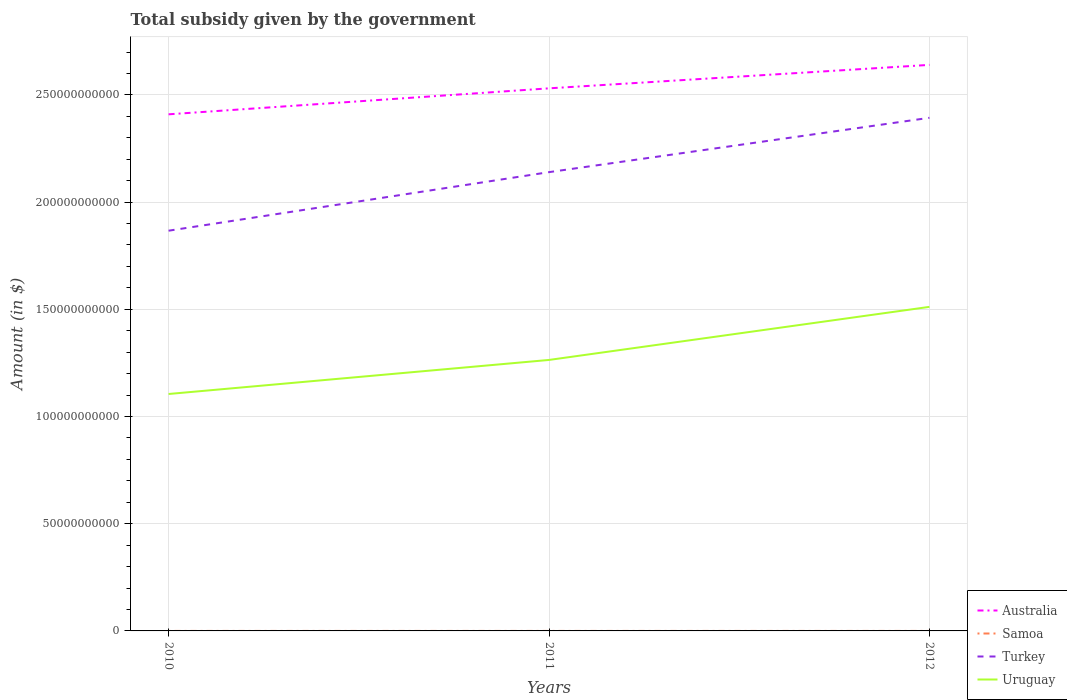Is the number of lines equal to the number of legend labels?
Give a very brief answer. Yes. Across all years, what is the maximum total revenue collected by the government in Uruguay?
Offer a very short reply. 1.11e+11. In which year was the total revenue collected by the government in Samoa maximum?
Your response must be concise. 2012. What is the total total revenue collected by the government in Turkey in the graph?
Make the answer very short. -2.53e+1. What is the difference between the highest and the second highest total revenue collected by the government in Australia?
Make the answer very short. 2.31e+1. What is the difference between two consecutive major ticks on the Y-axis?
Provide a succinct answer. 5.00e+1. Does the graph contain grids?
Ensure brevity in your answer.  Yes. Where does the legend appear in the graph?
Provide a succinct answer. Bottom right. How many legend labels are there?
Offer a very short reply. 4. How are the legend labels stacked?
Provide a short and direct response. Vertical. What is the title of the graph?
Offer a terse response. Total subsidy given by the government. Does "Guatemala" appear as one of the legend labels in the graph?
Your response must be concise. No. What is the label or title of the Y-axis?
Your answer should be very brief. Amount (in $). What is the Amount (in $) in Australia in 2010?
Offer a terse response. 2.41e+11. What is the Amount (in $) in Samoa in 2010?
Your answer should be compact. 1.88e+05. What is the Amount (in $) of Turkey in 2010?
Your response must be concise. 1.87e+11. What is the Amount (in $) of Uruguay in 2010?
Provide a short and direct response. 1.11e+11. What is the Amount (in $) in Australia in 2011?
Provide a short and direct response. 2.53e+11. What is the Amount (in $) in Samoa in 2011?
Your answer should be very brief. 1.84e+05. What is the Amount (in $) of Turkey in 2011?
Offer a very short reply. 2.14e+11. What is the Amount (in $) in Uruguay in 2011?
Provide a succinct answer. 1.26e+11. What is the Amount (in $) in Australia in 2012?
Provide a succinct answer. 2.64e+11. What is the Amount (in $) in Samoa in 2012?
Ensure brevity in your answer.  1.76e+05. What is the Amount (in $) of Turkey in 2012?
Provide a succinct answer. 2.39e+11. What is the Amount (in $) in Uruguay in 2012?
Provide a short and direct response. 1.51e+11. Across all years, what is the maximum Amount (in $) of Australia?
Offer a terse response. 2.64e+11. Across all years, what is the maximum Amount (in $) of Samoa?
Provide a short and direct response. 1.88e+05. Across all years, what is the maximum Amount (in $) in Turkey?
Provide a succinct answer. 2.39e+11. Across all years, what is the maximum Amount (in $) in Uruguay?
Keep it short and to the point. 1.51e+11. Across all years, what is the minimum Amount (in $) of Australia?
Provide a short and direct response. 2.41e+11. Across all years, what is the minimum Amount (in $) in Samoa?
Offer a very short reply. 1.76e+05. Across all years, what is the minimum Amount (in $) in Turkey?
Your answer should be very brief. 1.87e+11. Across all years, what is the minimum Amount (in $) of Uruguay?
Keep it short and to the point. 1.11e+11. What is the total Amount (in $) of Australia in the graph?
Keep it short and to the point. 7.58e+11. What is the total Amount (in $) of Samoa in the graph?
Provide a succinct answer. 5.48e+05. What is the total Amount (in $) of Turkey in the graph?
Offer a very short reply. 6.40e+11. What is the total Amount (in $) of Uruguay in the graph?
Provide a short and direct response. 3.88e+11. What is the difference between the Amount (in $) in Australia in 2010 and that in 2011?
Your response must be concise. -1.21e+1. What is the difference between the Amount (in $) of Samoa in 2010 and that in 2011?
Ensure brevity in your answer.  4748.99. What is the difference between the Amount (in $) in Turkey in 2010 and that in 2011?
Offer a very short reply. -2.73e+1. What is the difference between the Amount (in $) of Uruguay in 2010 and that in 2011?
Keep it short and to the point. -1.59e+1. What is the difference between the Amount (in $) in Australia in 2010 and that in 2012?
Your answer should be compact. -2.31e+1. What is the difference between the Amount (in $) in Samoa in 2010 and that in 2012?
Your answer should be compact. 1.25e+04. What is the difference between the Amount (in $) of Turkey in 2010 and that in 2012?
Ensure brevity in your answer.  -5.27e+1. What is the difference between the Amount (in $) in Uruguay in 2010 and that in 2012?
Give a very brief answer. -4.06e+1. What is the difference between the Amount (in $) of Australia in 2011 and that in 2012?
Your answer should be very brief. -1.09e+1. What is the difference between the Amount (in $) in Samoa in 2011 and that in 2012?
Keep it short and to the point. 7706.28. What is the difference between the Amount (in $) of Turkey in 2011 and that in 2012?
Provide a succinct answer. -2.53e+1. What is the difference between the Amount (in $) of Uruguay in 2011 and that in 2012?
Provide a short and direct response. -2.48e+1. What is the difference between the Amount (in $) in Australia in 2010 and the Amount (in $) in Samoa in 2011?
Offer a very short reply. 2.41e+11. What is the difference between the Amount (in $) of Australia in 2010 and the Amount (in $) of Turkey in 2011?
Ensure brevity in your answer.  2.70e+1. What is the difference between the Amount (in $) of Australia in 2010 and the Amount (in $) of Uruguay in 2011?
Keep it short and to the point. 1.15e+11. What is the difference between the Amount (in $) in Samoa in 2010 and the Amount (in $) in Turkey in 2011?
Give a very brief answer. -2.14e+11. What is the difference between the Amount (in $) in Samoa in 2010 and the Amount (in $) in Uruguay in 2011?
Provide a succinct answer. -1.26e+11. What is the difference between the Amount (in $) in Turkey in 2010 and the Amount (in $) in Uruguay in 2011?
Your answer should be very brief. 6.03e+1. What is the difference between the Amount (in $) of Australia in 2010 and the Amount (in $) of Samoa in 2012?
Ensure brevity in your answer.  2.41e+11. What is the difference between the Amount (in $) of Australia in 2010 and the Amount (in $) of Turkey in 2012?
Provide a short and direct response. 1.63e+09. What is the difference between the Amount (in $) of Australia in 2010 and the Amount (in $) of Uruguay in 2012?
Offer a very short reply. 8.98e+1. What is the difference between the Amount (in $) of Samoa in 2010 and the Amount (in $) of Turkey in 2012?
Keep it short and to the point. -2.39e+11. What is the difference between the Amount (in $) of Samoa in 2010 and the Amount (in $) of Uruguay in 2012?
Offer a terse response. -1.51e+11. What is the difference between the Amount (in $) in Turkey in 2010 and the Amount (in $) in Uruguay in 2012?
Ensure brevity in your answer.  3.55e+1. What is the difference between the Amount (in $) in Australia in 2011 and the Amount (in $) in Samoa in 2012?
Provide a succinct answer. 2.53e+11. What is the difference between the Amount (in $) of Australia in 2011 and the Amount (in $) of Turkey in 2012?
Offer a very short reply. 1.37e+1. What is the difference between the Amount (in $) in Australia in 2011 and the Amount (in $) in Uruguay in 2012?
Offer a terse response. 1.02e+11. What is the difference between the Amount (in $) in Samoa in 2011 and the Amount (in $) in Turkey in 2012?
Provide a succinct answer. -2.39e+11. What is the difference between the Amount (in $) in Samoa in 2011 and the Amount (in $) in Uruguay in 2012?
Your answer should be very brief. -1.51e+11. What is the difference between the Amount (in $) of Turkey in 2011 and the Amount (in $) of Uruguay in 2012?
Ensure brevity in your answer.  6.28e+1. What is the average Amount (in $) of Australia per year?
Offer a terse response. 2.53e+11. What is the average Amount (in $) in Samoa per year?
Your response must be concise. 1.83e+05. What is the average Amount (in $) of Turkey per year?
Offer a terse response. 2.13e+11. What is the average Amount (in $) in Uruguay per year?
Ensure brevity in your answer.  1.29e+11. In the year 2010, what is the difference between the Amount (in $) in Australia and Amount (in $) in Samoa?
Give a very brief answer. 2.41e+11. In the year 2010, what is the difference between the Amount (in $) of Australia and Amount (in $) of Turkey?
Provide a short and direct response. 5.43e+1. In the year 2010, what is the difference between the Amount (in $) in Australia and Amount (in $) in Uruguay?
Keep it short and to the point. 1.30e+11. In the year 2010, what is the difference between the Amount (in $) of Samoa and Amount (in $) of Turkey?
Keep it short and to the point. -1.87e+11. In the year 2010, what is the difference between the Amount (in $) in Samoa and Amount (in $) in Uruguay?
Offer a terse response. -1.11e+11. In the year 2010, what is the difference between the Amount (in $) of Turkey and Amount (in $) of Uruguay?
Make the answer very short. 7.62e+1. In the year 2011, what is the difference between the Amount (in $) in Australia and Amount (in $) in Samoa?
Your response must be concise. 2.53e+11. In the year 2011, what is the difference between the Amount (in $) of Australia and Amount (in $) of Turkey?
Ensure brevity in your answer.  3.91e+1. In the year 2011, what is the difference between the Amount (in $) in Australia and Amount (in $) in Uruguay?
Offer a very short reply. 1.27e+11. In the year 2011, what is the difference between the Amount (in $) in Samoa and Amount (in $) in Turkey?
Your answer should be compact. -2.14e+11. In the year 2011, what is the difference between the Amount (in $) of Samoa and Amount (in $) of Uruguay?
Offer a very short reply. -1.26e+11. In the year 2011, what is the difference between the Amount (in $) in Turkey and Amount (in $) in Uruguay?
Make the answer very short. 8.76e+1. In the year 2012, what is the difference between the Amount (in $) of Australia and Amount (in $) of Samoa?
Your answer should be very brief. 2.64e+11. In the year 2012, what is the difference between the Amount (in $) in Australia and Amount (in $) in Turkey?
Make the answer very short. 2.47e+1. In the year 2012, what is the difference between the Amount (in $) in Australia and Amount (in $) in Uruguay?
Give a very brief answer. 1.13e+11. In the year 2012, what is the difference between the Amount (in $) in Samoa and Amount (in $) in Turkey?
Keep it short and to the point. -2.39e+11. In the year 2012, what is the difference between the Amount (in $) in Samoa and Amount (in $) in Uruguay?
Make the answer very short. -1.51e+11. In the year 2012, what is the difference between the Amount (in $) of Turkey and Amount (in $) of Uruguay?
Ensure brevity in your answer.  8.82e+1. What is the ratio of the Amount (in $) in Australia in 2010 to that in 2011?
Offer a very short reply. 0.95. What is the ratio of the Amount (in $) in Samoa in 2010 to that in 2011?
Provide a short and direct response. 1.03. What is the ratio of the Amount (in $) in Turkey in 2010 to that in 2011?
Your response must be concise. 0.87. What is the ratio of the Amount (in $) in Uruguay in 2010 to that in 2011?
Ensure brevity in your answer.  0.87. What is the ratio of the Amount (in $) of Australia in 2010 to that in 2012?
Make the answer very short. 0.91. What is the ratio of the Amount (in $) of Samoa in 2010 to that in 2012?
Ensure brevity in your answer.  1.07. What is the ratio of the Amount (in $) in Turkey in 2010 to that in 2012?
Your answer should be very brief. 0.78. What is the ratio of the Amount (in $) of Uruguay in 2010 to that in 2012?
Offer a very short reply. 0.73. What is the ratio of the Amount (in $) in Australia in 2011 to that in 2012?
Offer a terse response. 0.96. What is the ratio of the Amount (in $) in Samoa in 2011 to that in 2012?
Keep it short and to the point. 1.04. What is the ratio of the Amount (in $) of Turkey in 2011 to that in 2012?
Your answer should be compact. 0.89. What is the ratio of the Amount (in $) in Uruguay in 2011 to that in 2012?
Ensure brevity in your answer.  0.84. What is the difference between the highest and the second highest Amount (in $) in Australia?
Your answer should be compact. 1.09e+1. What is the difference between the highest and the second highest Amount (in $) in Samoa?
Your response must be concise. 4748.99. What is the difference between the highest and the second highest Amount (in $) of Turkey?
Provide a succinct answer. 2.53e+1. What is the difference between the highest and the second highest Amount (in $) in Uruguay?
Offer a terse response. 2.48e+1. What is the difference between the highest and the lowest Amount (in $) in Australia?
Your answer should be very brief. 2.31e+1. What is the difference between the highest and the lowest Amount (in $) of Samoa?
Offer a terse response. 1.25e+04. What is the difference between the highest and the lowest Amount (in $) in Turkey?
Offer a terse response. 5.27e+1. What is the difference between the highest and the lowest Amount (in $) of Uruguay?
Ensure brevity in your answer.  4.06e+1. 